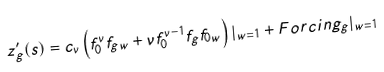Convert formula to latex. <formula><loc_0><loc_0><loc_500><loc_500>z _ { g } ^ { \prime } ( s ) = c _ { \nu } \left ( f _ { 0 } ^ { \nu } f _ { g w } + \nu f _ { 0 } ^ { \nu - 1 } f _ { g } f _ { 0 w } \right ) | _ { w = 1 } + F o r c i n g _ { g } | _ { w = 1 }</formula> 